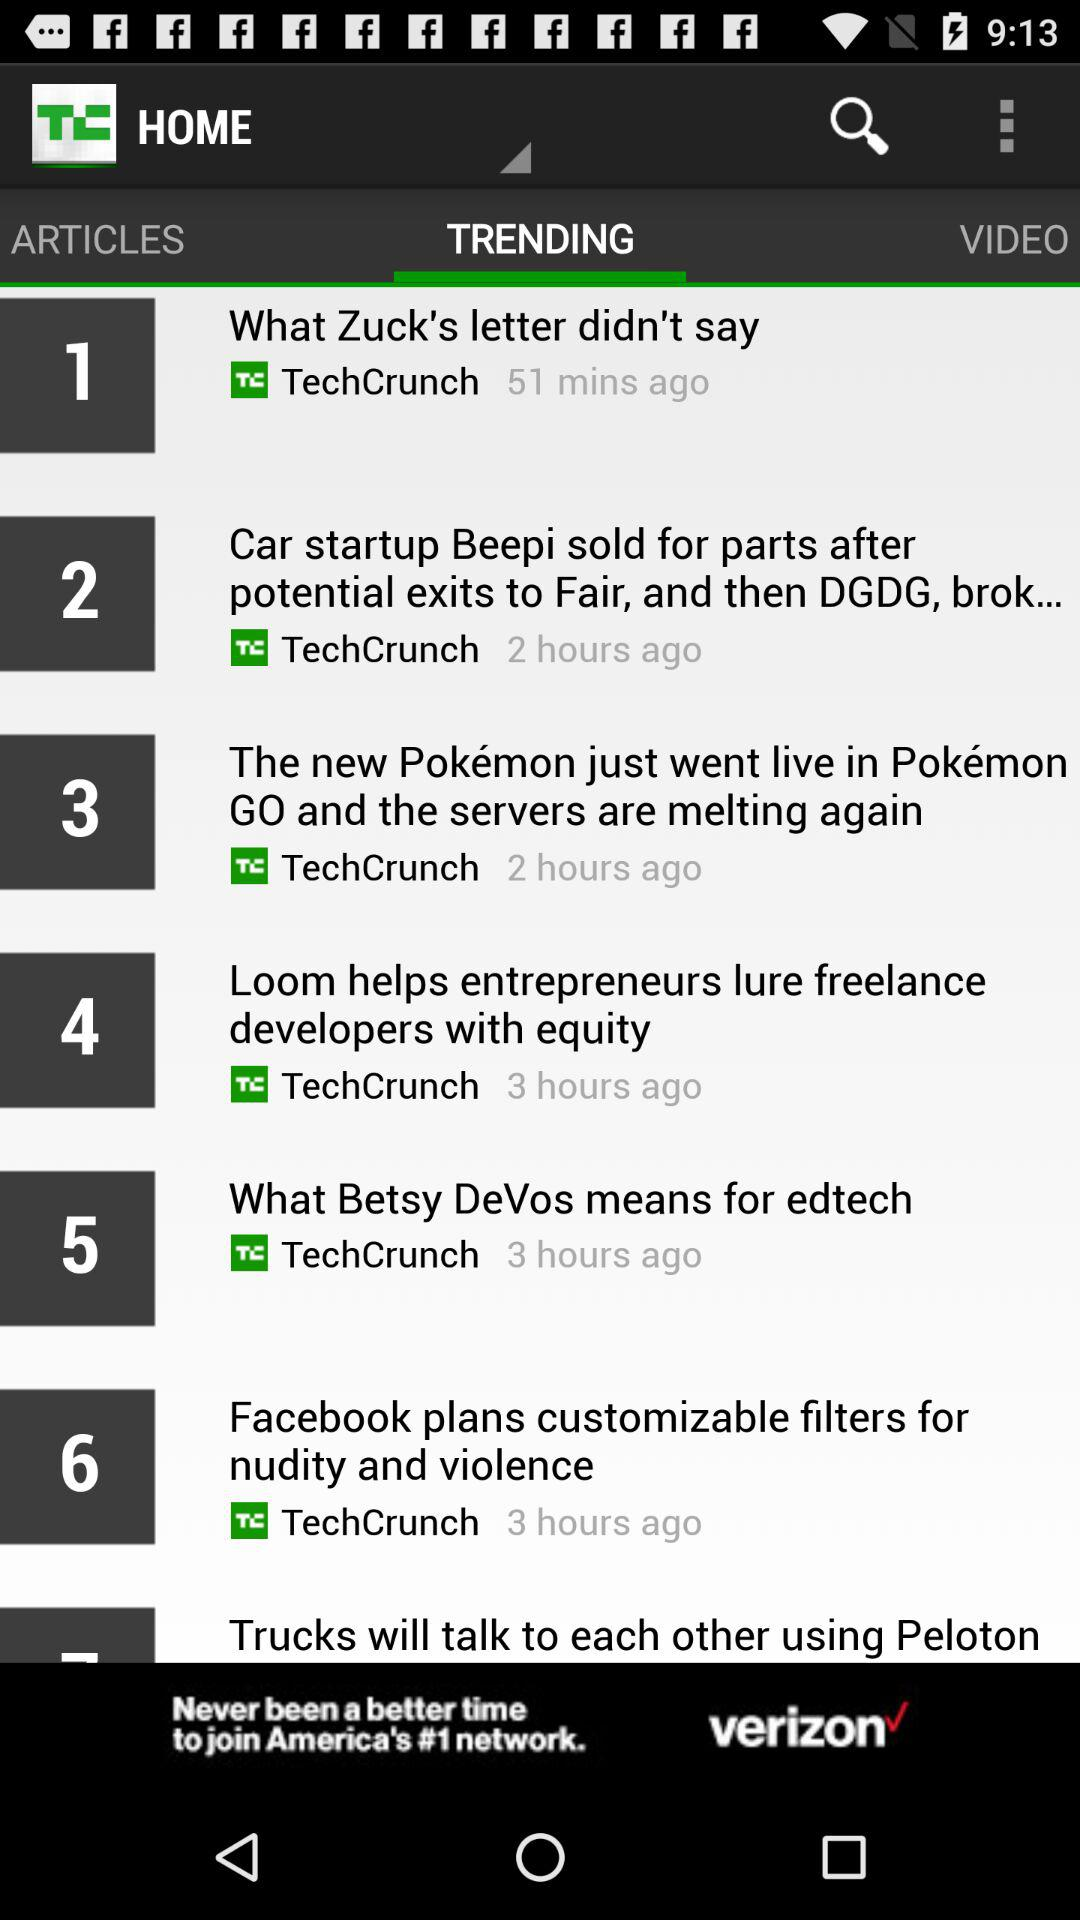What's the name of the publisher of Article Number 4? The publisher is "TechCrunch". 